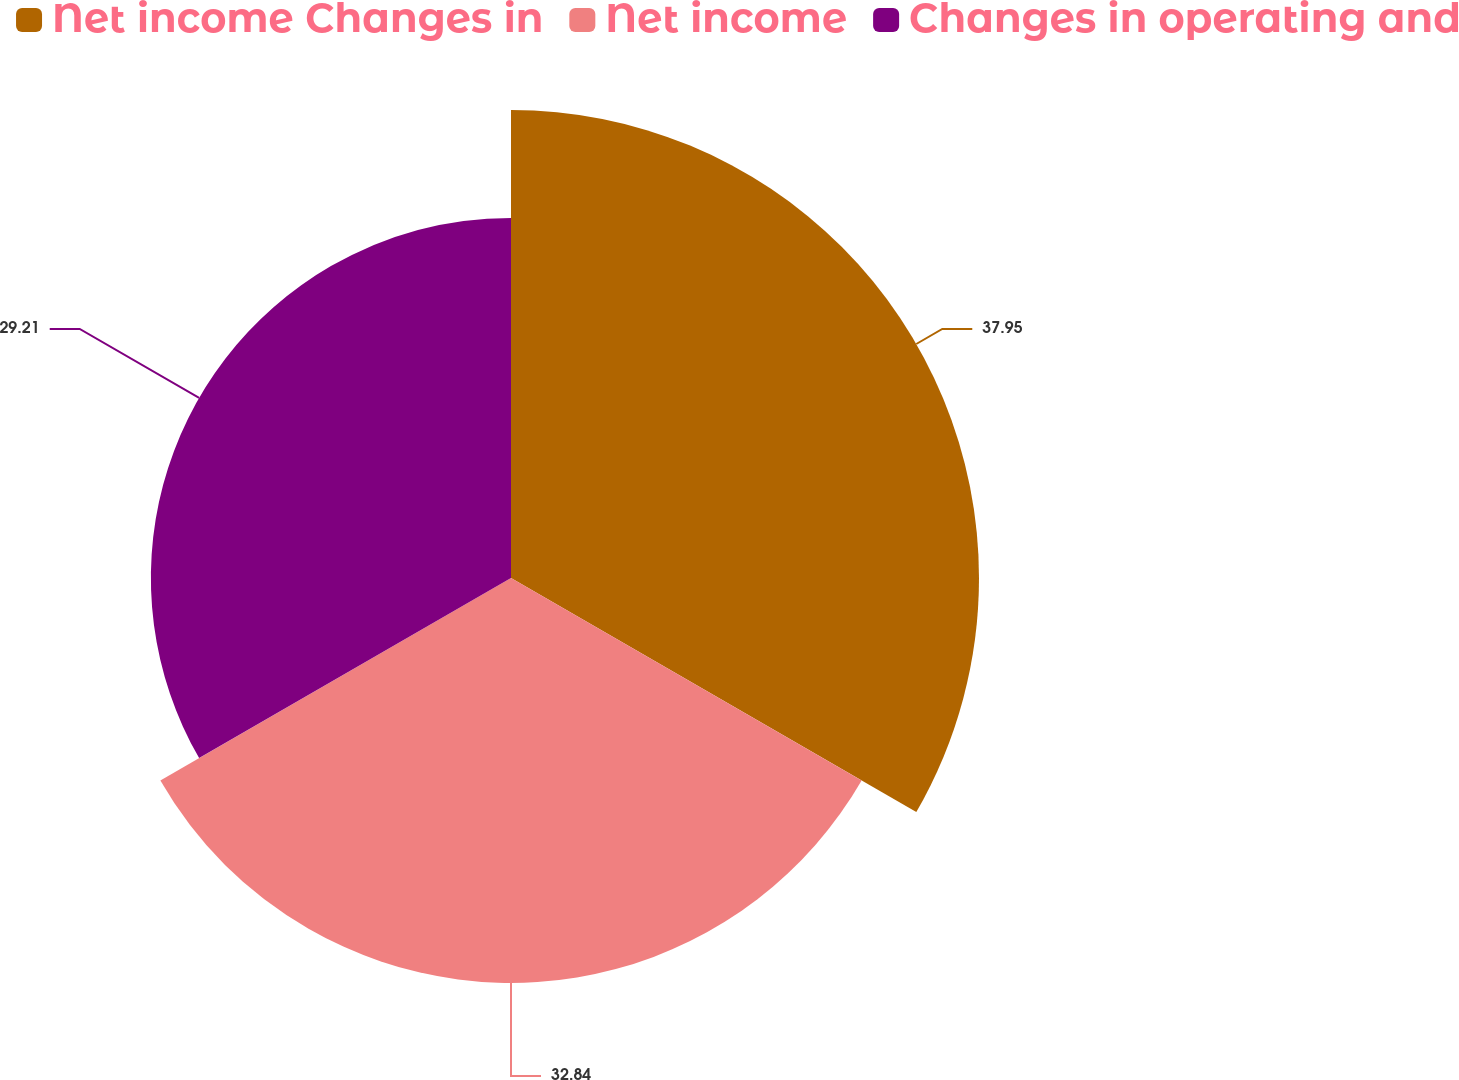Convert chart. <chart><loc_0><loc_0><loc_500><loc_500><pie_chart><fcel>Net income Changes in<fcel>Net income<fcel>Changes in operating and<nl><fcel>37.96%<fcel>32.84%<fcel>29.21%<nl></chart> 